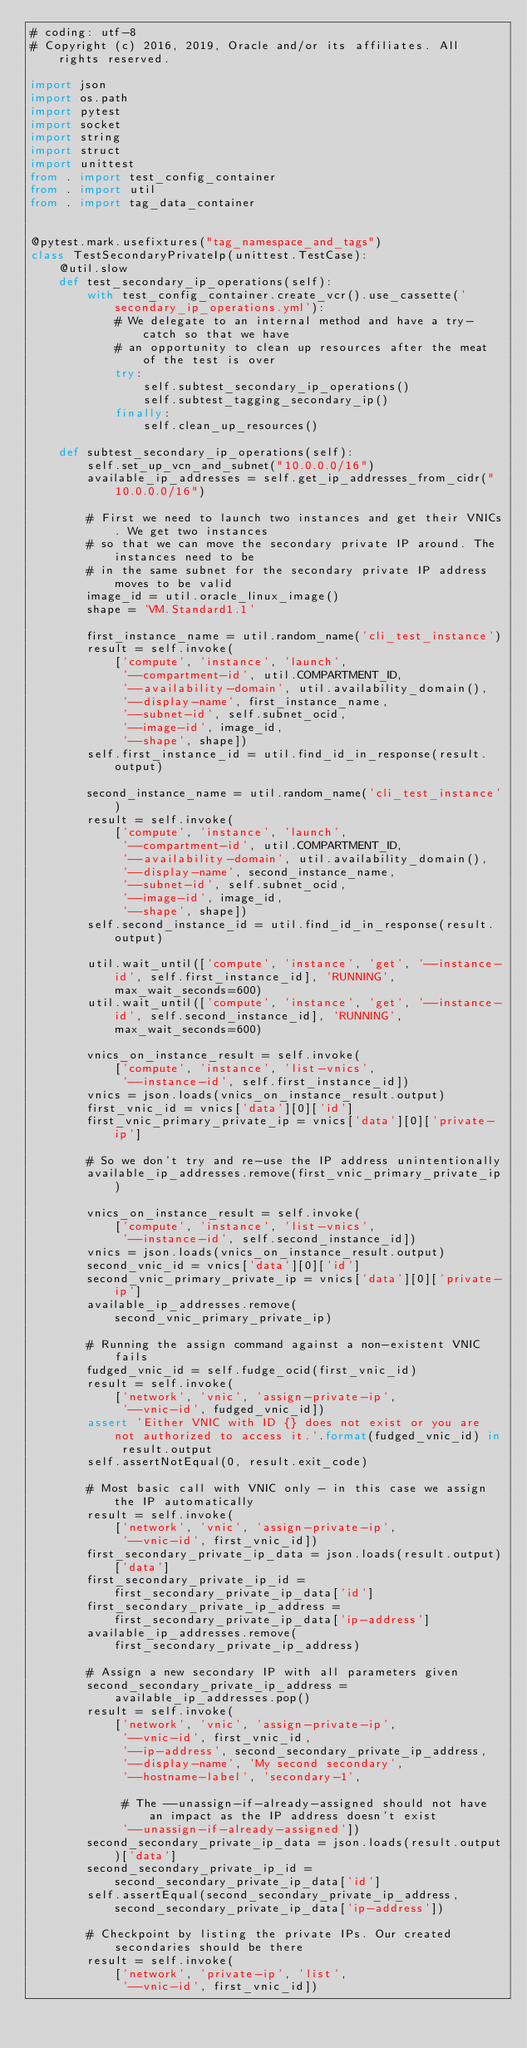<code> <loc_0><loc_0><loc_500><loc_500><_Python_># coding: utf-8
# Copyright (c) 2016, 2019, Oracle and/or its affiliates. All rights reserved.

import json
import os.path
import pytest
import socket
import string
import struct
import unittest
from . import test_config_container
from . import util
from . import tag_data_container


@pytest.mark.usefixtures("tag_namespace_and_tags")
class TestSecondaryPrivateIp(unittest.TestCase):
    @util.slow
    def test_secondary_ip_operations(self):
        with test_config_container.create_vcr().use_cassette('secondary_ip_operations.yml'):
            # We delegate to an internal method and have a try-catch so that we have
            # an opportunity to clean up resources after the meat of the test is over
            try:
                self.subtest_secondary_ip_operations()
                self.subtest_tagging_secondary_ip()
            finally:
                self.clean_up_resources()

    def subtest_secondary_ip_operations(self):
        self.set_up_vcn_and_subnet("10.0.0.0/16")
        available_ip_addresses = self.get_ip_addresses_from_cidr("10.0.0.0/16")

        # First we need to launch two instances and get their VNICs. We get two instances
        # so that we can move the secondary private IP around. The instances need to be
        # in the same subnet for the secondary private IP address moves to be valid
        image_id = util.oracle_linux_image()
        shape = 'VM.Standard1.1'

        first_instance_name = util.random_name('cli_test_instance')
        result = self.invoke(
            ['compute', 'instance', 'launch',
             '--compartment-id', util.COMPARTMENT_ID,
             '--availability-domain', util.availability_domain(),
             '--display-name', first_instance_name,
             '--subnet-id', self.subnet_ocid,
             '--image-id', image_id,
             '--shape', shape])
        self.first_instance_id = util.find_id_in_response(result.output)

        second_instance_name = util.random_name('cli_test_instance')
        result = self.invoke(
            ['compute', 'instance', 'launch',
             '--compartment-id', util.COMPARTMENT_ID,
             '--availability-domain', util.availability_domain(),
             '--display-name', second_instance_name,
             '--subnet-id', self.subnet_ocid,
             '--image-id', image_id,
             '--shape', shape])
        self.second_instance_id = util.find_id_in_response(result.output)

        util.wait_until(['compute', 'instance', 'get', '--instance-id', self.first_instance_id], 'RUNNING', max_wait_seconds=600)
        util.wait_until(['compute', 'instance', 'get', '--instance-id', self.second_instance_id], 'RUNNING', max_wait_seconds=600)

        vnics_on_instance_result = self.invoke(
            ['compute', 'instance', 'list-vnics',
             '--instance-id', self.first_instance_id])
        vnics = json.loads(vnics_on_instance_result.output)
        first_vnic_id = vnics['data'][0]['id']
        first_vnic_primary_private_ip = vnics['data'][0]['private-ip']

        # So we don't try and re-use the IP address unintentionally
        available_ip_addresses.remove(first_vnic_primary_private_ip)

        vnics_on_instance_result = self.invoke(
            ['compute', 'instance', 'list-vnics',
             '--instance-id', self.second_instance_id])
        vnics = json.loads(vnics_on_instance_result.output)
        second_vnic_id = vnics['data'][0]['id']
        second_vnic_primary_private_ip = vnics['data'][0]['private-ip']
        available_ip_addresses.remove(second_vnic_primary_private_ip)

        # Running the assign command against a non-existent VNIC fails
        fudged_vnic_id = self.fudge_ocid(first_vnic_id)
        result = self.invoke(
            ['network', 'vnic', 'assign-private-ip',
             '--vnic-id', fudged_vnic_id])
        assert 'Either VNIC with ID {} does not exist or you are not authorized to access it.'.format(fudged_vnic_id) in result.output
        self.assertNotEqual(0, result.exit_code)

        # Most basic call with VNIC only - in this case we assign the IP automatically
        result = self.invoke(
            ['network', 'vnic', 'assign-private-ip',
             '--vnic-id', first_vnic_id])
        first_secondary_private_ip_data = json.loads(result.output)['data']
        first_secondary_private_ip_id = first_secondary_private_ip_data['id']
        first_secondary_private_ip_address = first_secondary_private_ip_data['ip-address']
        available_ip_addresses.remove(first_secondary_private_ip_address)

        # Assign a new secondary IP with all parameters given
        second_secondary_private_ip_address = available_ip_addresses.pop()
        result = self.invoke(
            ['network', 'vnic', 'assign-private-ip',
             '--vnic-id', first_vnic_id,
             '--ip-address', second_secondary_private_ip_address,
             '--display-name', 'My second secondary',
             '--hostname-label', 'secondary-1',

             # The --unassign-if-already-assigned should not have an impact as the IP address doesn't exist
             '--unassign-if-already-assigned'])
        second_secondary_private_ip_data = json.loads(result.output)['data']
        second_secondary_private_ip_id = second_secondary_private_ip_data['id']
        self.assertEqual(second_secondary_private_ip_address, second_secondary_private_ip_data['ip-address'])

        # Checkpoint by listing the private IPs. Our created secondaries should be there
        result = self.invoke(
            ['network', 'private-ip', 'list',
             '--vnic-id', first_vnic_id])</code> 